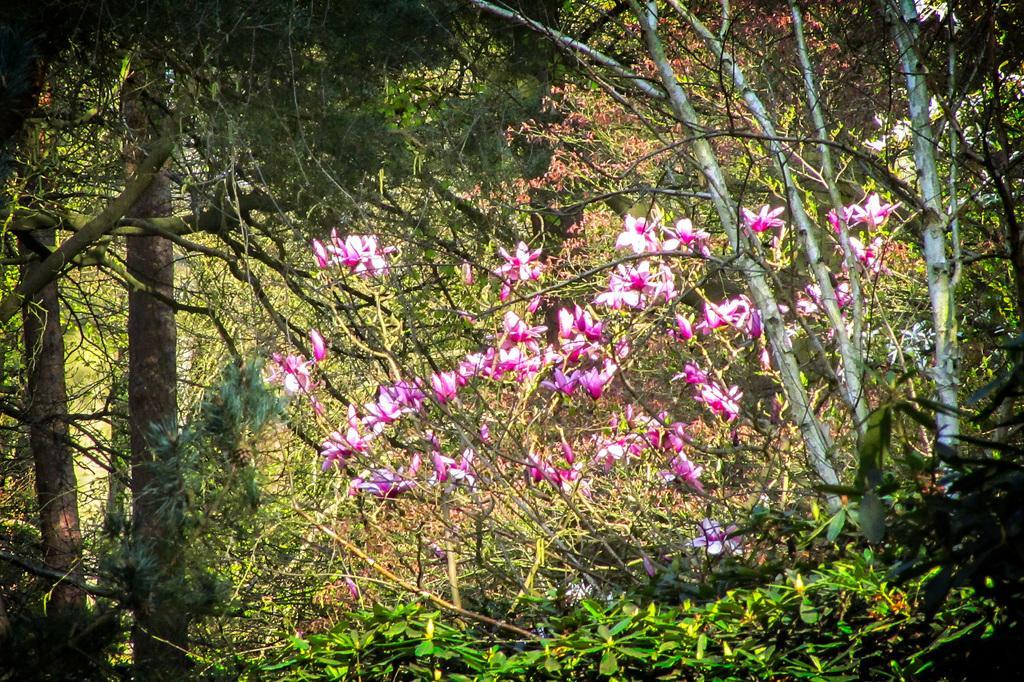How would you summarize this image in a sentence or two? In this image, we can see trees and there are flowers. 